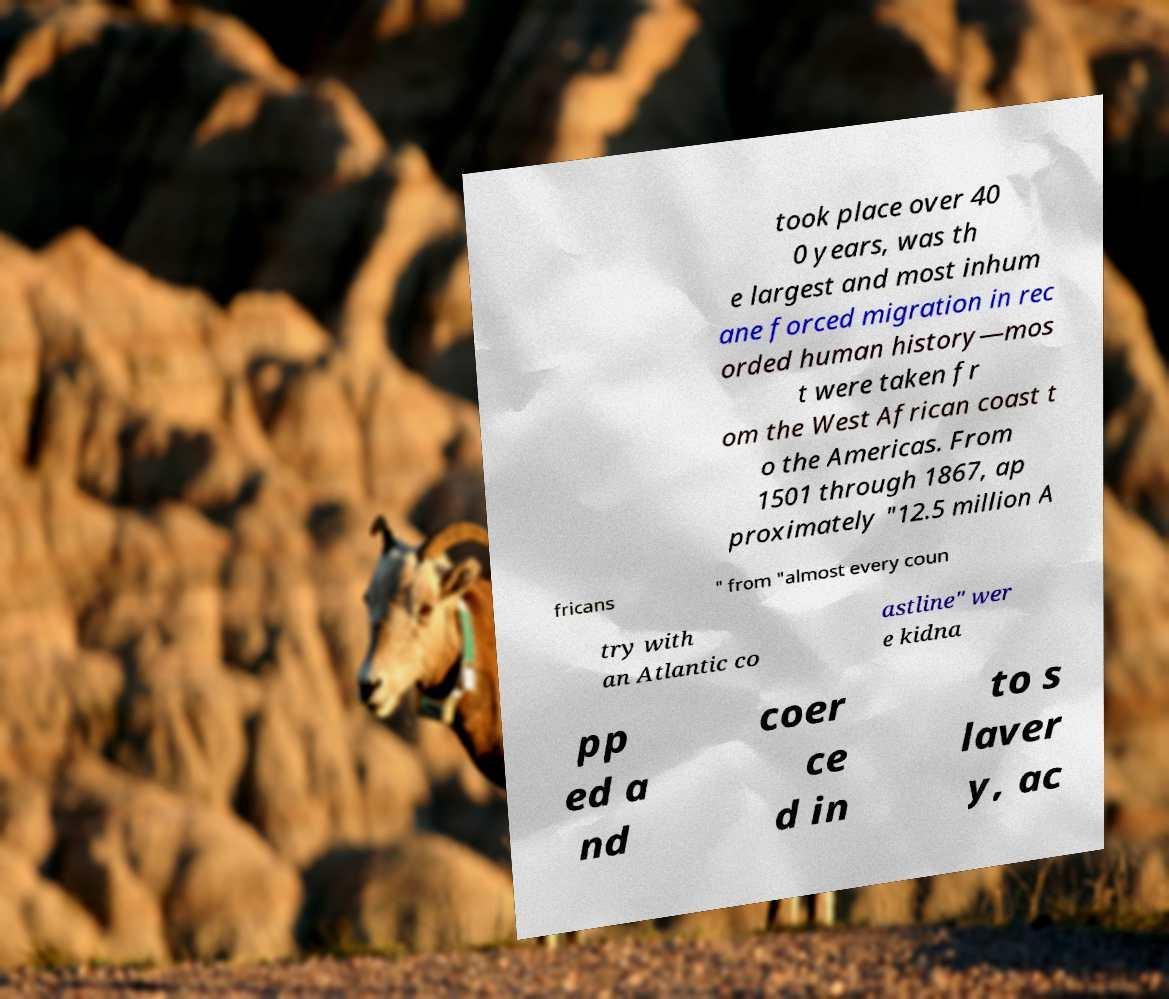I need the written content from this picture converted into text. Can you do that? took place over 40 0 years, was th e largest and most inhum ane forced migration in rec orded human history—mos t were taken fr om the West African coast t o the Americas. From 1501 through 1867, ap proximately "12.5 million A fricans " from "almost every coun try with an Atlantic co astline" wer e kidna pp ed a nd coer ce d in to s laver y, ac 